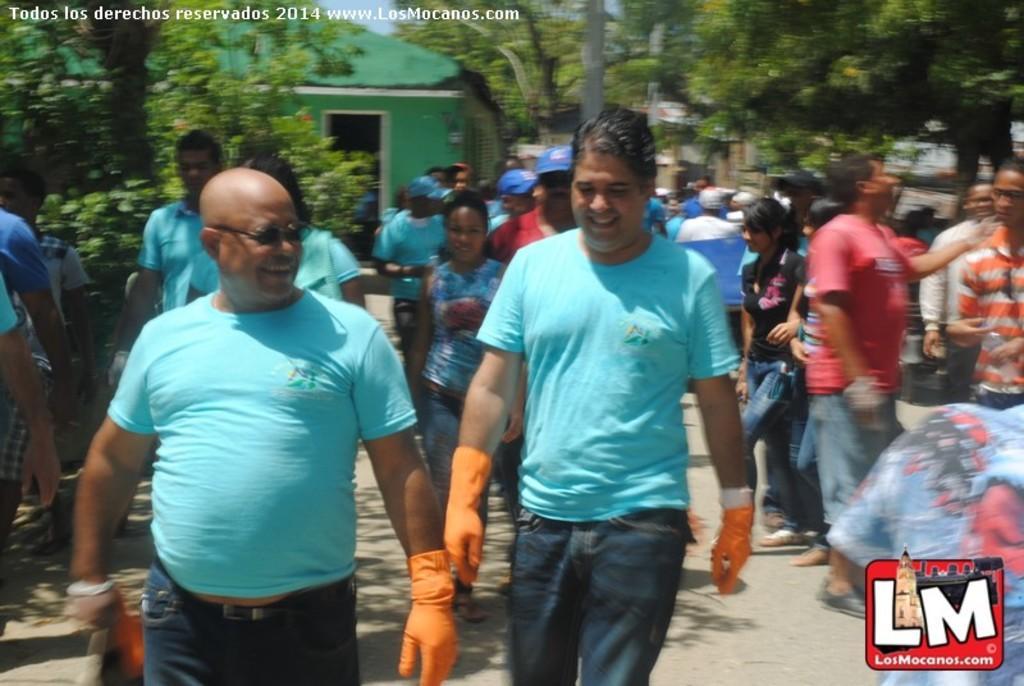Could you give a brief overview of what you see in this image? In this image, we can see some people walking, on the right side, there are some people standing, we can see some trees and there is a house. 